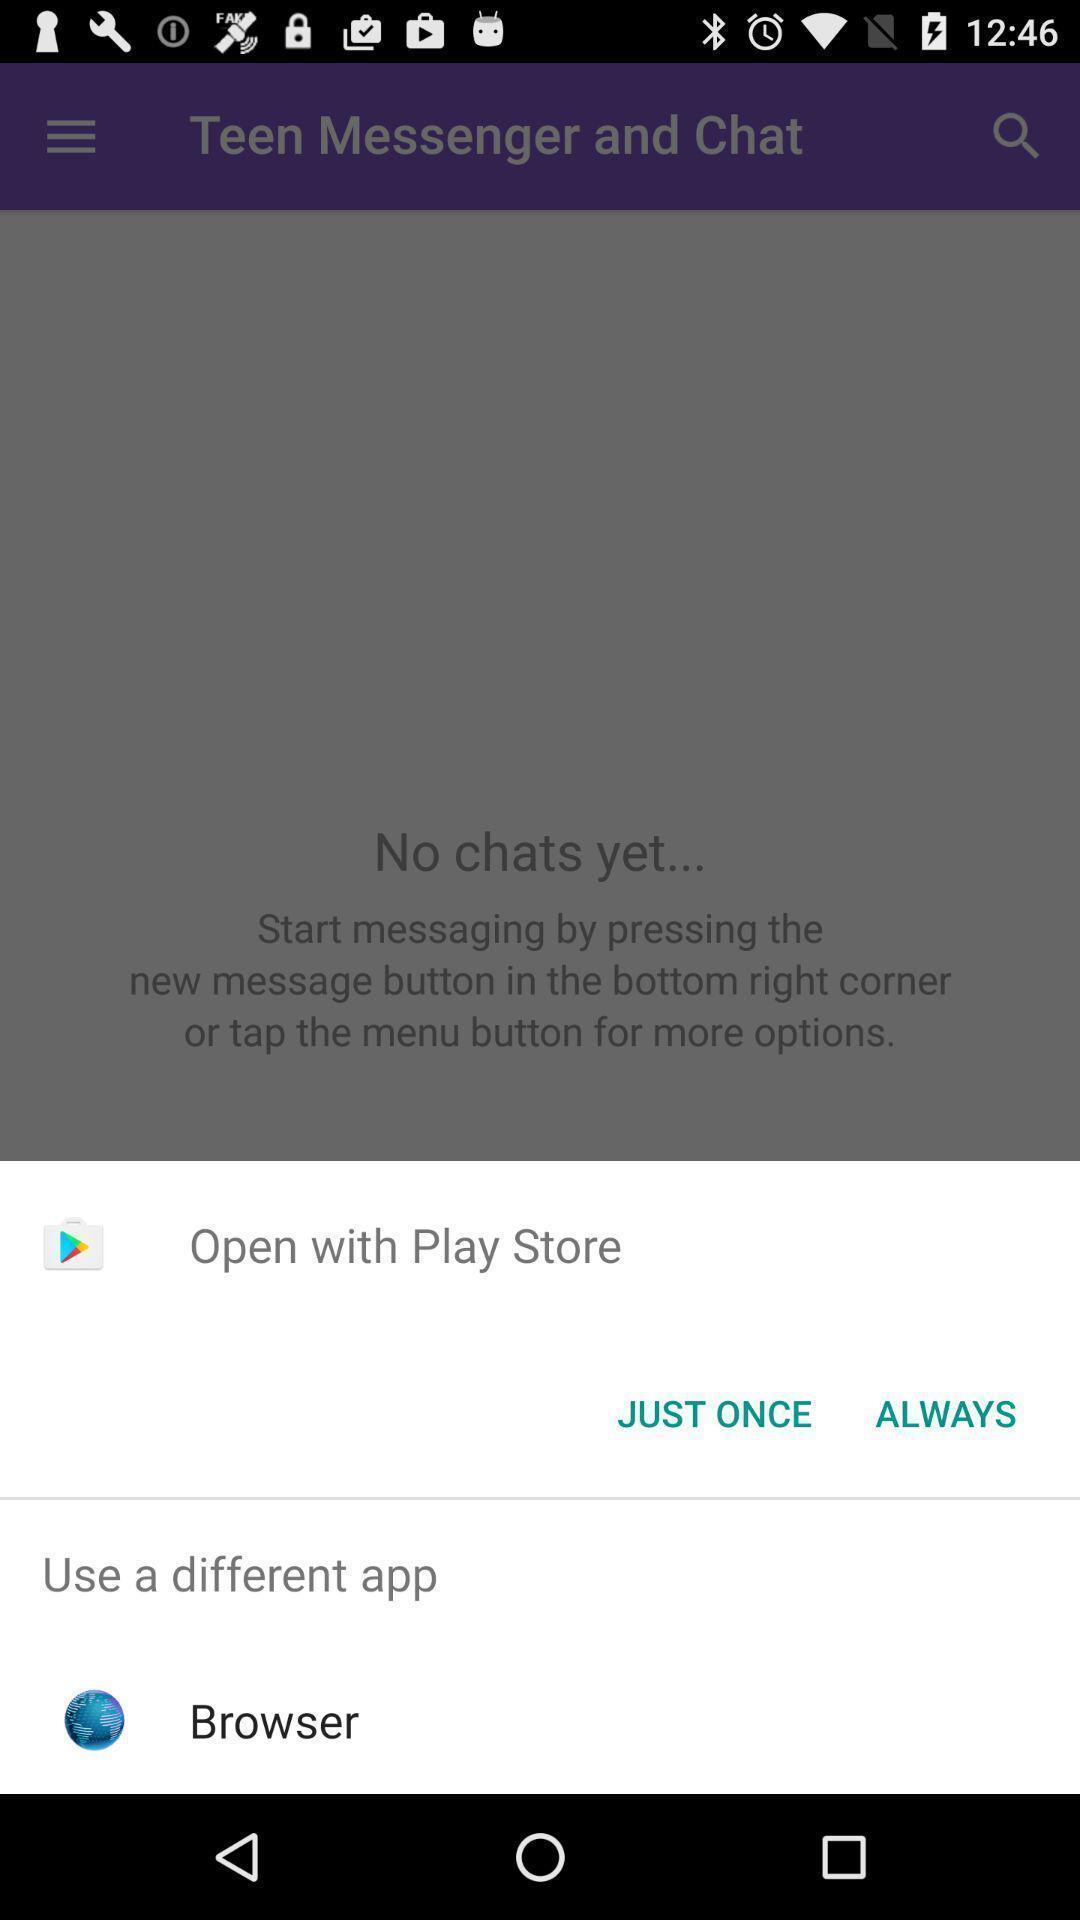What can you discern from this picture? Pop-up showing options to open a browser. 